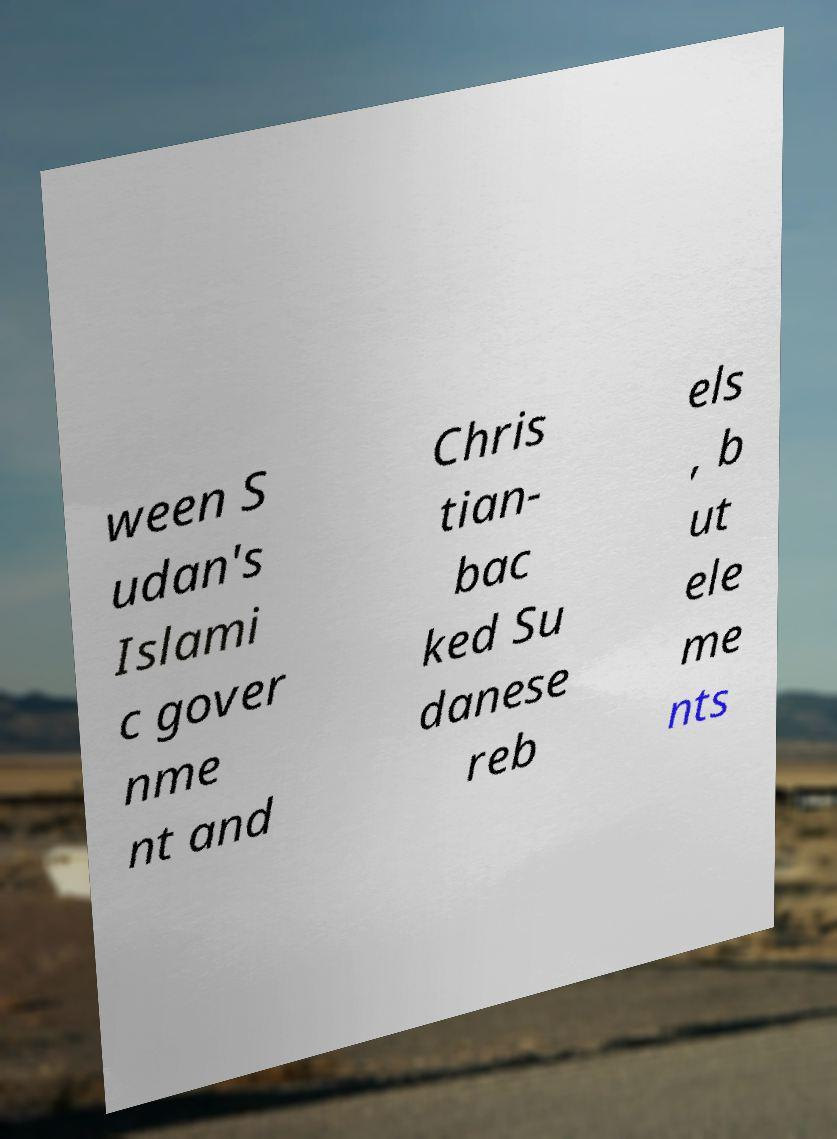Could you extract and type out the text from this image? ween S udan's Islami c gover nme nt and Chris tian- bac ked Su danese reb els , b ut ele me nts 